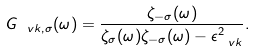Convert formula to latex. <formula><loc_0><loc_0><loc_500><loc_500>G _ { \ v k , \sigma } ( \omega ) = \frac { \zeta _ { - \sigma } ( \omega ) } { \zeta _ { \sigma } ( \omega ) \zeta _ { - \sigma } ( \omega ) - \epsilon _ { \ v k } ^ { 2 } } .</formula> 